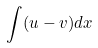<formula> <loc_0><loc_0><loc_500><loc_500>\int ( u - v ) d x</formula> 